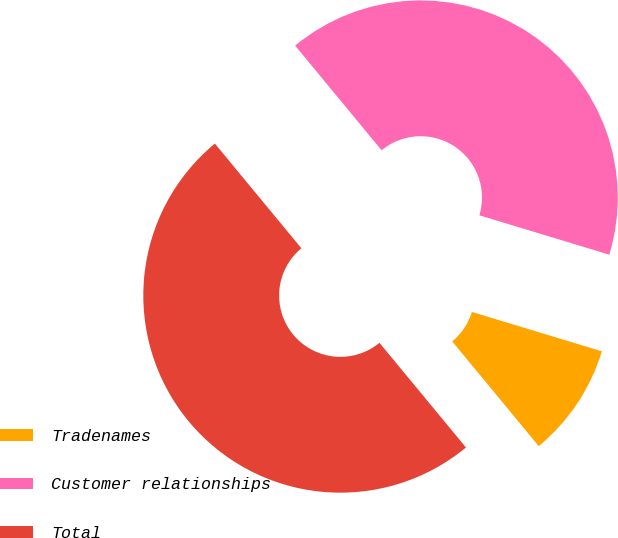Convert chart. <chart><loc_0><loc_0><loc_500><loc_500><pie_chart><fcel>Tradenames<fcel>Customer relationships<fcel>Total<nl><fcel>9.33%<fcel>40.67%<fcel>50.0%<nl></chart> 